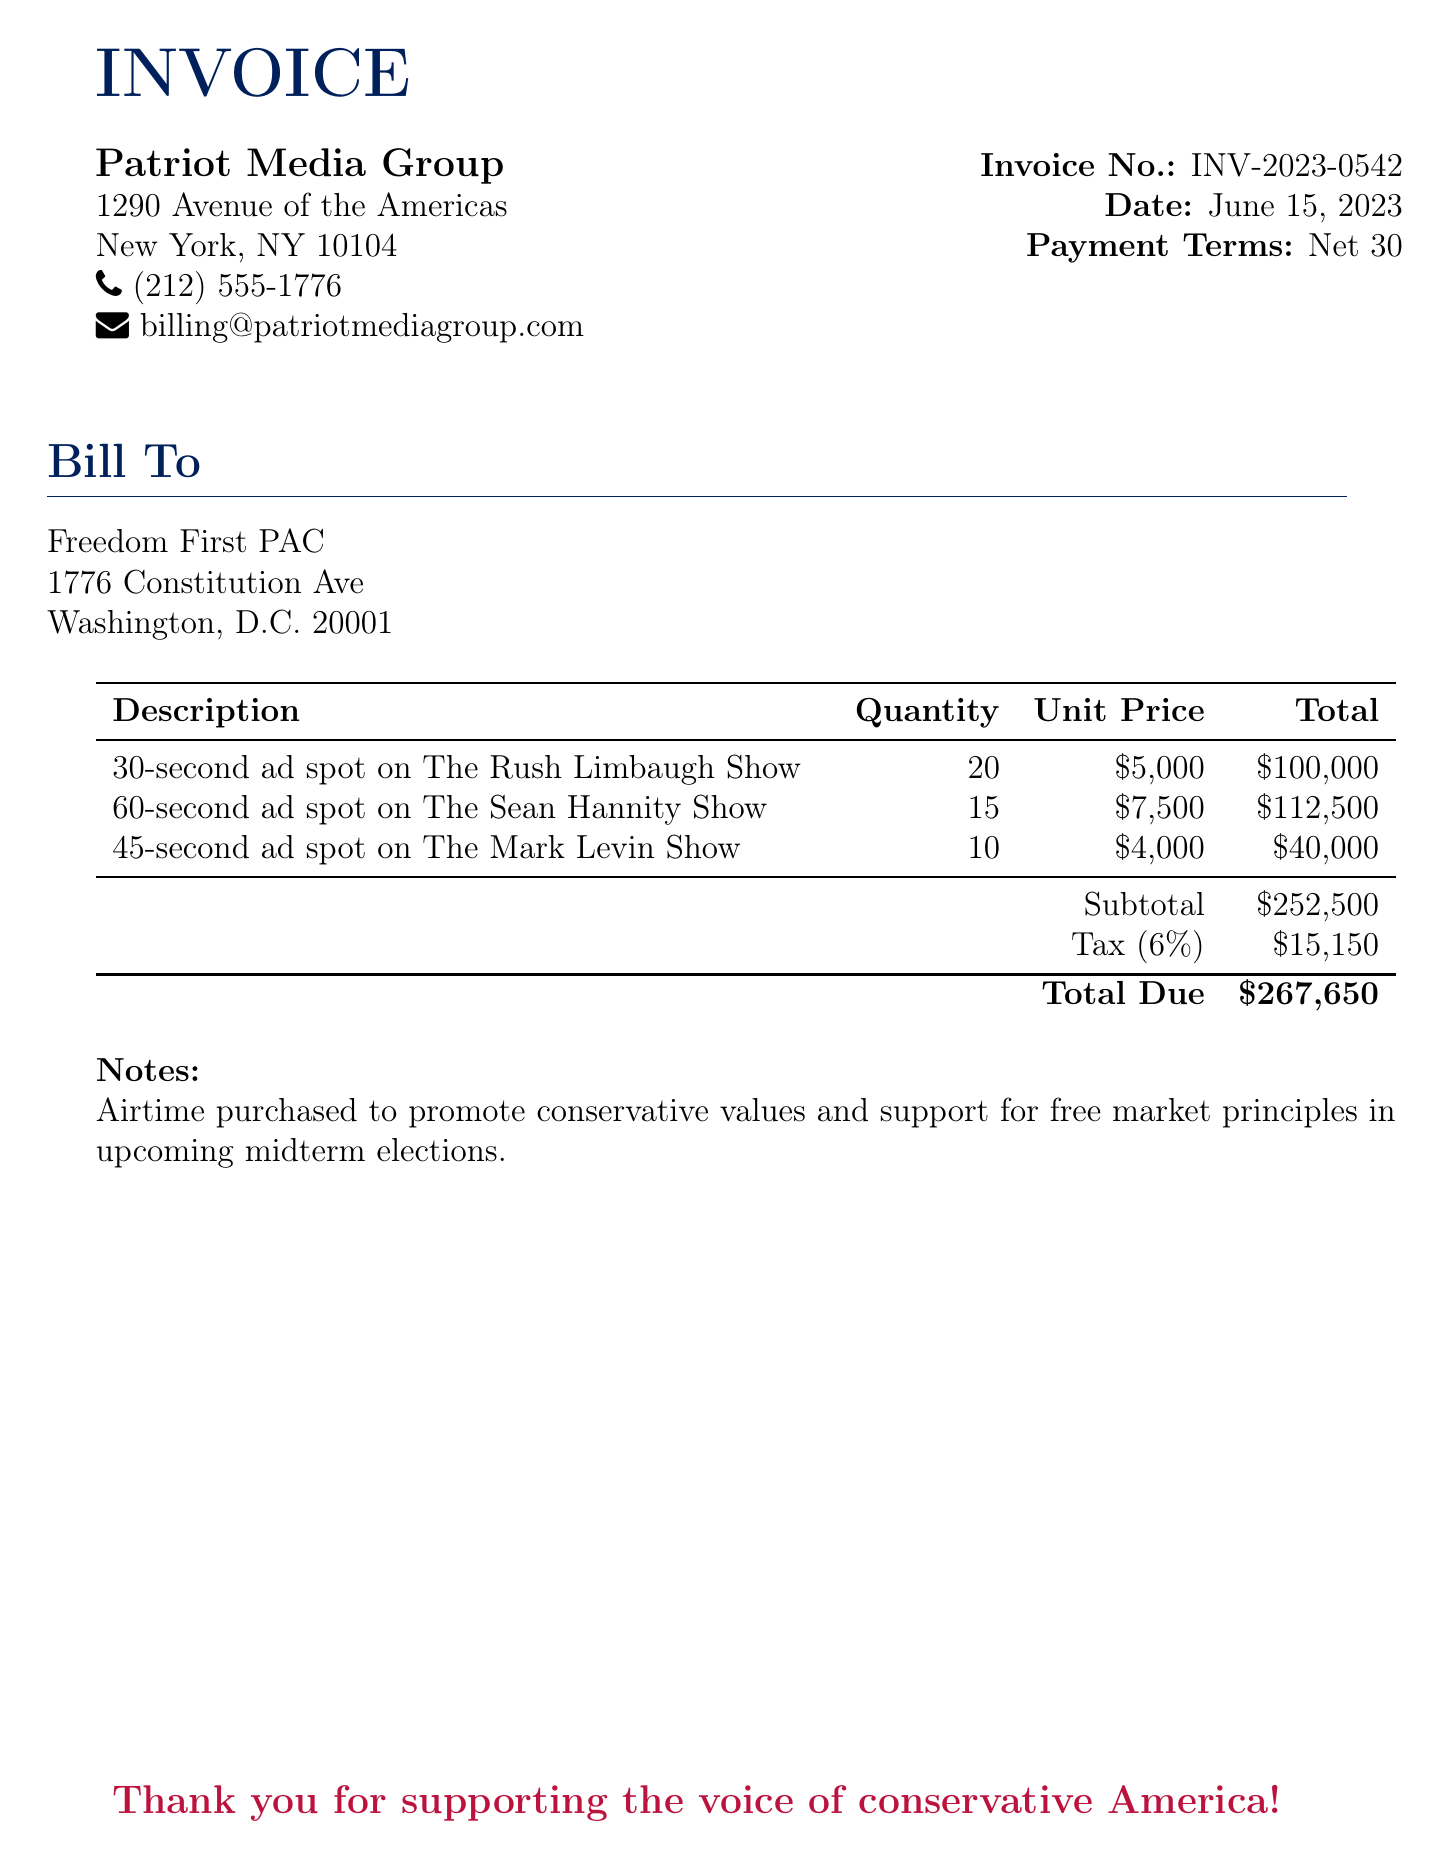what is the invoice number? The invoice number is stated in the document as INV-2023-0542.
Answer: INV-2023-0542 what is the total due? The total due is calculated at the end of the invoice, which is $267,650.
Answer: $267,650 who is the bill to? The recipient of the bill is specified as Freedom First PAC.
Answer: Freedom First PAC when was the invoice dated? The date of the invoice is provided, which is June 15, 2023.
Answer: June 15, 2023 what is the tax rate applied? The document indicates that the tax rate applied is 6%.
Answer: 6% how many 30-second ad spots were purchased? The document lists the quantity of 30-second ad spots purchased as 20.
Answer: 20 what is the subtotal before tax? The subtotal before tax is specified in the invoice as $252,500.
Answer: $252,500 what is the purpose of the airtime purchase? The notes mention that the airtime purchase is to promote conservative values and support for free market principles.
Answer: promote conservative values and support for free market principles how many spots were purchased on The Sean Hannity Show? The invoice specifies that 15 ad spots were purchased on The Sean Hannity Show.
Answer: 15 